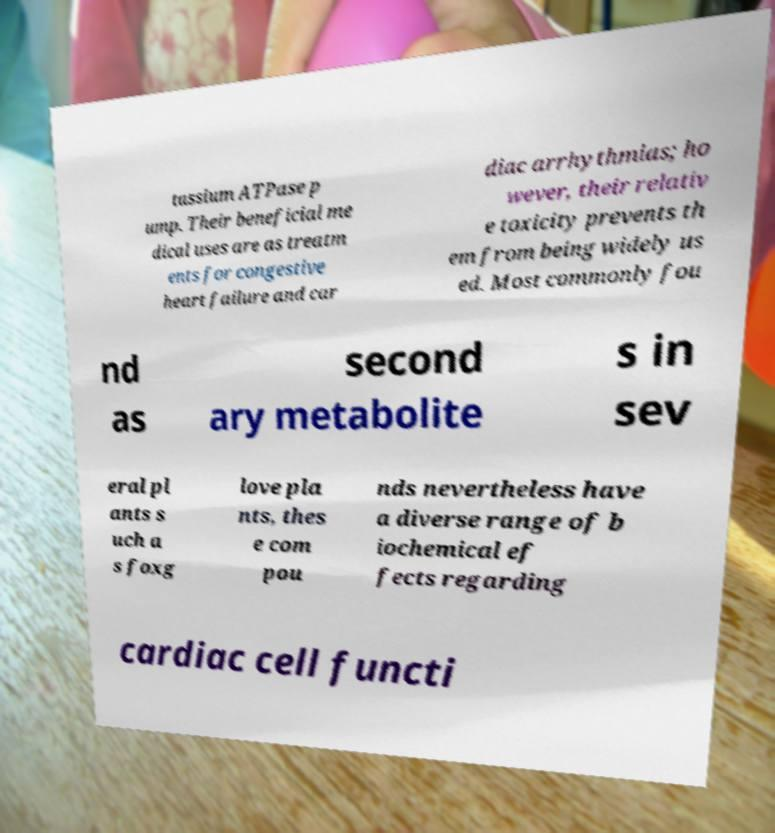I need the written content from this picture converted into text. Can you do that? tassium ATPase p ump. Their beneficial me dical uses are as treatm ents for congestive heart failure and car diac arrhythmias; ho wever, their relativ e toxicity prevents th em from being widely us ed. Most commonly fou nd as second ary metabolite s in sev eral pl ants s uch a s foxg love pla nts, thes e com pou nds nevertheless have a diverse range of b iochemical ef fects regarding cardiac cell functi 